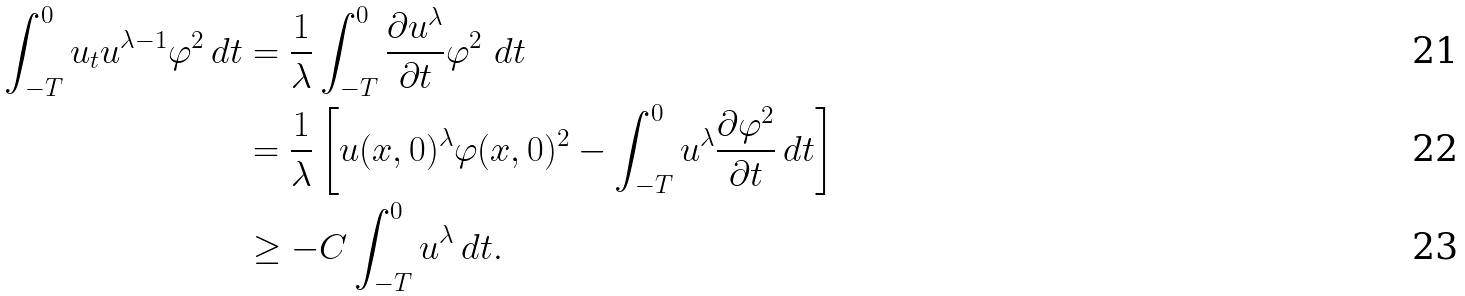<formula> <loc_0><loc_0><loc_500><loc_500>\int ^ { 0 } _ { - T } u _ { t } u ^ { \lambda - 1 } \varphi ^ { 2 } \, d t & = \frac { 1 } { \lambda } \int ^ { 0 } _ { - T } \frac { \partial u ^ { \lambda } } { \partial t } \varphi ^ { 2 } \ d t \\ & = \frac { 1 } { \lambda } \left [ u ( x , 0 ) ^ { \lambda } \varphi ( x , 0 ) ^ { 2 } - \int ^ { 0 } _ { - T } u ^ { \lambda } \frac { \partial \varphi ^ { 2 } } { \partial t } \, d t \right ] \\ & \geq - C \int ^ { 0 } _ { - T } u ^ { \lambda } \, d t .</formula> 